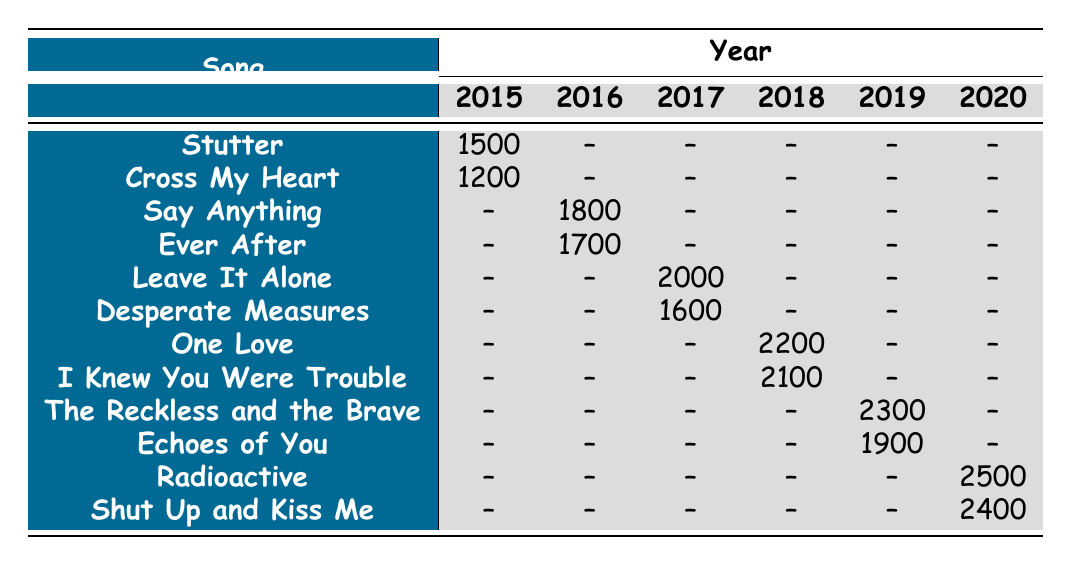What was the highest attendance in 2019? The songs performed in 2019 were "The Reckless and the Brave" with an attendance of 2300 and "Echoes of You" with an attendance of 1900. The highest of these two is 2300.
Answer: 2300 Which song had the lowest attendance in 2015? In 2015, the songs performed were "Stutter" with 1500 attendees and "Cross My Heart" with 1200 attendees. The lowest attendance in this year is 1200 from "Cross My Heart."
Answer: 1200 Did every year have at least one song performed? Every year listed from 2015 to 2020 has at least one song performed, as seen from the table where each year has corresponding attendance figures.
Answer: Yes What is the total attendance for songs performed in 2016? The songs performed in 2016 include "Say Anything" (1800) and "Ever After" (1700). Adding both gives a total of 1800 + 1700 = 3500.
Answer: 3500 How many songs were performed in 2017? In 2017, two songs were listed: "Leave It Alone" and "Desperate Measures," which means the total number of songs performed that year is 2.
Answer: 2 Which year had the highest overall attendance, and what was that total? The year with the highest total attendance is 2020, with "Radioactive" (2500) and "Shut Up and Kiss Me" (2400), making the total for 2020: 2500 + 2400 = 4900.
Answer: 2020, 4900 Is "I Knew You Were Trouble" performed in 2015? "I Knew You Were Trouble" is listed under 2018, not 2015, which makes the statement false.
Answer: No What was the difference in attendance between the highest and lowest attended songs in 2018? The highest attended song in 2018 is "One Love" (2200) and the lowest is "I Knew You Were Trouble" (2100). The difference is 2200 - 2100 = 100.
Answer: 100 